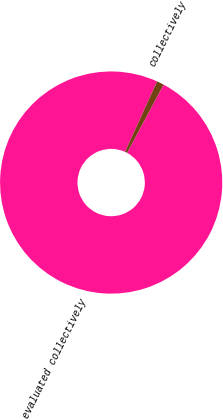<chart> <loc_0><loc_0><loc_500><loc_500><pie_chart><fcel>evaluated collectively<fcel>collectively<nl><fcel>98.96%<fcel>1.04%<nl></chart> 